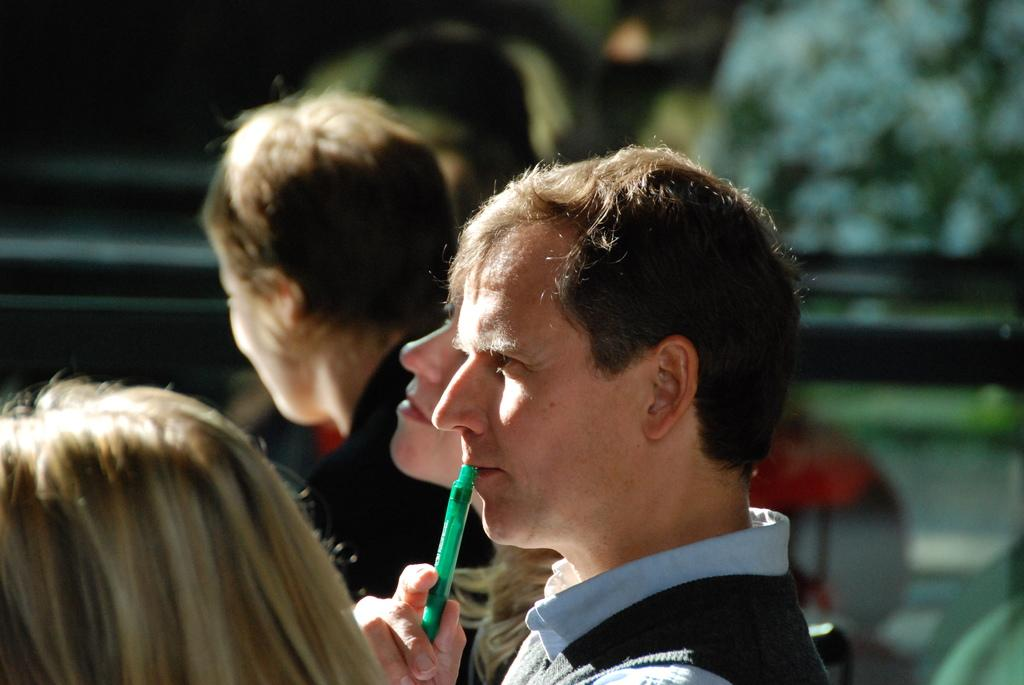How many people are in the image? There are multiple persons in the image. Can you describe the gender of the people in the image? Some of the persons are men, and some are women. Who is the person in the middle of the group? The person in the middle is holding a pen near their mouth. What type of frogs can be seen in the image? There are no frogs present in the image. What season is it in the image? The provided facts do not mention any season or weather-related information, so it cannot be determined from the image. 